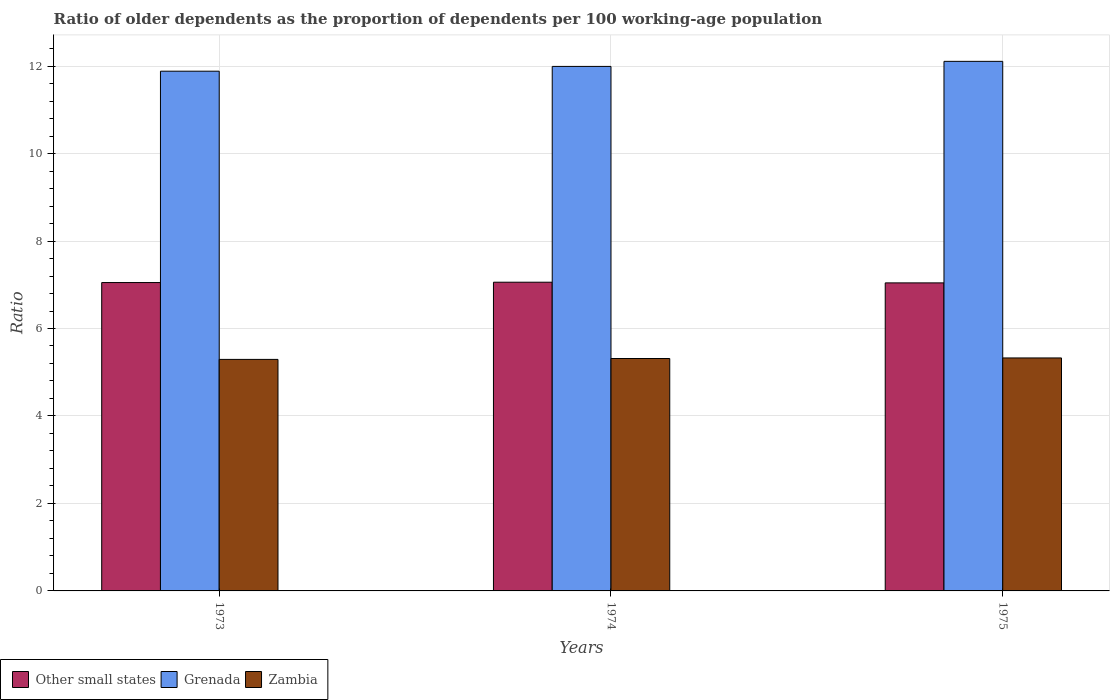How many different coloured bars are there?
Your response must be concise. 3. Are the number of bars per tick equal to the number of legend labels?
Make the answer very short. Yes. What is the label of the 3rd group of bars from the left?
Your response must be concise. 1975. What is the age dependency ratio(old) in Grenada in 1973?
Provide a short and direct response. 11.88. Across all years, what is the maximum age dependency ratio(old) in Other small states?
Your answer should be compact. 7.06. Across all years, what is the minimum age dependency ratio(old) in Zambia?
Ensure brevity in your answer.  5.29. In which year was the age dependency ratio(old) in Other small states maximum?
Provide a short and direct response. 1974. In which year was the age dependency ratio(old) in Grenada minimum?
Your answer should be compact. 1973. What is the total age dependency ratio(old) in Grenada in the graph?
Ensure brevity in your answer.  35.98. What is the difference between the age dependency ratio(old) in Zambia in 1973 and that in 1974?
Offer a terse response. -0.02. What is the difference between the age dependency ratio(old) in Other small states in 1973 and the age dependency ratio(old) in Zambia in 1975?
Keep it short and to the point. 1.72. What is the average age dependency ratio(old) in Other small states per year?
Provide a short and direct response. 7.05. In the year 1975, what is the difference between the age dependency ratio(old) in Other small states and age dependency ratio(old) in Zambia?
Provide a succinct answer. 1.72. In how many years, is the age dependency ratio(old) in Zambia greater than 9.2?
Your response must be concise. 0. What is the ratio of the age dependency ratio(old) in Zambia in 1974 to that in 1975?
Provide a succinct answer. 1. Is the difference between the age dependency ratio(old) in Other small states in 1973 and 1975 greater than the difference between the age dependency ratio(old) in Zambia in 1973 and 1975?
Offer a terse response. Yes. What is the difference between the highest and the second highest age dependency ratio(old) in Other small states?
Provide a short and direct response. 0.01. What is the difference between the highest and the lowest age dependency ratio(old) in Zambia?
Make the answer very short. 0.03. In how many years, is the age dependency ratio(old) in Zambia greater than the average age dependency ratio(old) in Zambia taken over all years?
Your answer should be very brief. 2. What does the 2nd bar from the left in 1974 represents?
Ensure brevity in your answer.  Grenada. What does the 2nd bar from the right in 1975 represents?
Provide a short and direct response. Grenada. How many bars are there?
Make the answer very short. 9. Are all the bars in the graph horizontal?
Your answer should be compact. No. How many years are there in the graph?
Provide a short and direct response. 3. What is the difference between two consecutive major ticks on the Y-axis?
Your answer should be compact. 2. Are the values on the major ticks of Y-axis written in scientific E-notation?
Give a very brief answer. No. Does the graph contain any zero values?
Keep it short and to the point. No. How are the legend labels stacked?
Provide a succinct answer. Horizontal. What is the title of the graph?
Provide a short and direct response. Ratio of older dependents as the proportion of dependents per 100 working-age population. Does "Caribbean small states" appear as one of the legend labels in the graph?
Provide a succinct answer. No. What is the label or title of the X-axis?
Provide a short and direct response. Years. What is the label or title of the Y-axis?
Keep it short and to the point. Ratio. What is the Ratio of Other small states in 1973?
Provide a succinct answer. 7.05. What is the Ratio of Grenada in 1973?
Offer a terse response. 11.88. What is the Ratio of Zambia in 1973?
Your answer should be very brief. 5.29. What is the Ratio of Other small states in 1974?
Give a very brief answer. 7.06. What is the Ratio in Grenada in 1974?
Offer a very short reply. 11.99. What is the Ratio in Zambia in 1974?
Your answer should be very brief. 5.31. What is the Ratio in Other small states in 1975?
Ensure brevity in your answer.  7.04. What is the Ratio in Grenada in 1975?
Keep it short and to the point. 12.11. What is the Ratio in Zambia in 1975?
Keep it short and to the point. 5.33. Across all years, what is the maximum Ratio of Other small states?
Your answer should be very brief. 7.06. Across all years, what is the maximum Ratio in Grenada?
Offer a terse response. 12.11. Across all years, what is the maximum Ratio of Zambia?
Provide a short and direct response. 5.33. Across all years, what is the minimum Ratio of Other small states?
Offer a very short reply. 7.04. Across all years, what is the minimum Ratio of Grenada?
Your answer should be very brief. 11.88. Across all years, what is the minimum Ratio of Zambia?
Ensure brevity in your answer.  5.29. What is the total Ratio in Other small states in the graph?
Provide a short and direct response. 21.15. What is the total Ratio of Grenada in the graph?
Your answer should be very brief. 35.98. What is the total Ratio in Zambia in the graph?
Provide a short and direct response. 15.93. What is the difference between the Ratio of Other small states in 1973 and that in 1974?
Your answer should be very brief. -0.01. What is the difference between the Ratio of Grenada in 1973 and that in 1974?
Offer a terse response. -0.11. What is the difference between the Ratio of Zambia in 1973 and that in 1974?
Your response must be concise. -0.02. What is the difference between the Ratio of Other small states in 1973 and that in 1975?
Your answer should be compact. 0.01. What is the difference between the Ratio in Grenada in 1973 and that in 1975?
Keep it short and to the point. -0.23. What is the difference between the Ratio in Zambia in 1973 and that in 1975?
Ensure brevity in your answer.  -0.03. What is the difference between the Ratio of Other small states in 1974 and that in 1975?
Your response must be concise. 0.02. What is the difference between the Ratio of Grenada in 1974 and that in 1975?
Your answer should be very brief. -0.12. What is the difference between the Ratio in Zambia in 1974 and that in 1975?
Your response must be concise. -0.01. What is the difference between the Ratio of Other small states in 1973 and the Ratio of Grenada in 1974?
Your answer should be compact. -4.94. What is the difference between the Ratio of Other small states in 1973 and the Ratio of Zambia in 1974?
Give a very brief answer. 1.74. What is the difference between the Ratio in Grenada in 1973 and the Ratio in Zambia in 1974?
Offer a terse response. 6.57. What is the difference between the Ratio in Other small states in 1973 and the Ratio in Grenada in 1975?
Offer a very short reply. -5.06. What is the difference between the Ratio in Other small states in 1973 and the Ratio in Zambia in 1975?
Give a very brief answer. 1.72. What is the difference between the Ratio of Grenada in 1973 and the Ratio of Zambia in 1975?
Provide a short and direct response. 6.56. What is the difference between the Ratio of Other small states in 1974 and the Ratio of Grenada in 1975?
Provide a short and direct response. -5.05. What is the difference between the Ratio of Other small states in 1974 and the Ratio of Zambia in 1975?
Your answer should be compact. 1.73. What is the difference between the Ratio of Grenada in 1974 and the Ratio of Zambia in 1975?
Keep it short and to the point. 6.67. What is the average Ratio in Other small states per year?
Provide a succinct answer. 7.05. What is the average Ratio in Grenada per year?
Keep it short and to the point. 11.99. What is the average Ratio in Zambia per year?
Provide a short and direct response. 5.31. In the year 1973, what is the difference between the Ratio in Other small states and Ratio in Grenada?
Provide a succinct answer. -4.83. In the year 1973, what is the difference between the Ratio in Other small states and Ratio in Zambia?
Provide a short and direct response. 1.76. In the year 1973, what is the difference between the Ratio of Grenada and Ratio of Zambia?
Offer a terse response. 6.59. In the year 1974, what is the difference between the Ratio in Other small states and Ratio in Grenada?
Offer a very short reply. -4.93. In the year 1974, what is the difference between the Ratio of Other small states and Ratio of Zambia?
Provide a succinct answer. 1.74. In the year 1974, what is the difference between the Ratio of Grenada and Ratio of Zambia?
Ensure brevity in your answer.  6.68. In the year 1975, what is the difference between the Ratio of Other small states and Ratio of Grenada?
Provide a short and direct response. -5.07. In the year 1975, what is the difference between the Ratio in Other small states and Ratio in Zambia?
Provide a succinct answer. 1.72. In the year 1975, what is the difference between the Ratio in Grenada and Ratio in Zambia?
Your response must be concise. 6.78. What is the ratio of the Ratio of Other small states in 1973 to that in 1974?
Offer a very short reply. 1. What is the ratio of the Ratio in Grenada in 1973 to that in 1974?
Offer a very short reply. 0.99. What is the ratio of the Ratio of Other small states in 1973 to that in 1975?
Your answer should be very brief. 1. What is the ratio of the Ratio of Grenada in 1973 to that in 1975?
Make the answer very short. 0.98. What is the ratio of the Ratio in Zambia in 1973 to that in 1975?
Keep it short and to the point. 0.99. What is the ratio of the Ratio of Other small states in 1974 to that in 1975?
Offer a terse response. 1. What is the difference between the highest and the second highest Ratio in Other small states?
Your answer should be very brief. 0.01. What is the difference between the highest and the second highest Ratio of Grenada?
Your answer should be very brief. 0.12. What is the difference between the highest and the second highest Ratio in Zambia?
Offer a very short reply. 0.01. What is the difference between the highest and the lowest Ratio of Other small states?
Provide a succinct answer. 0.02. What is the difference between the highest and the lowest Ratio in Grenada?
Ensure brevity in your answer.  0.23. What is the difference between the highest and the lowest Ratio of Zambia?
Offer a very short reply. 0.03. 